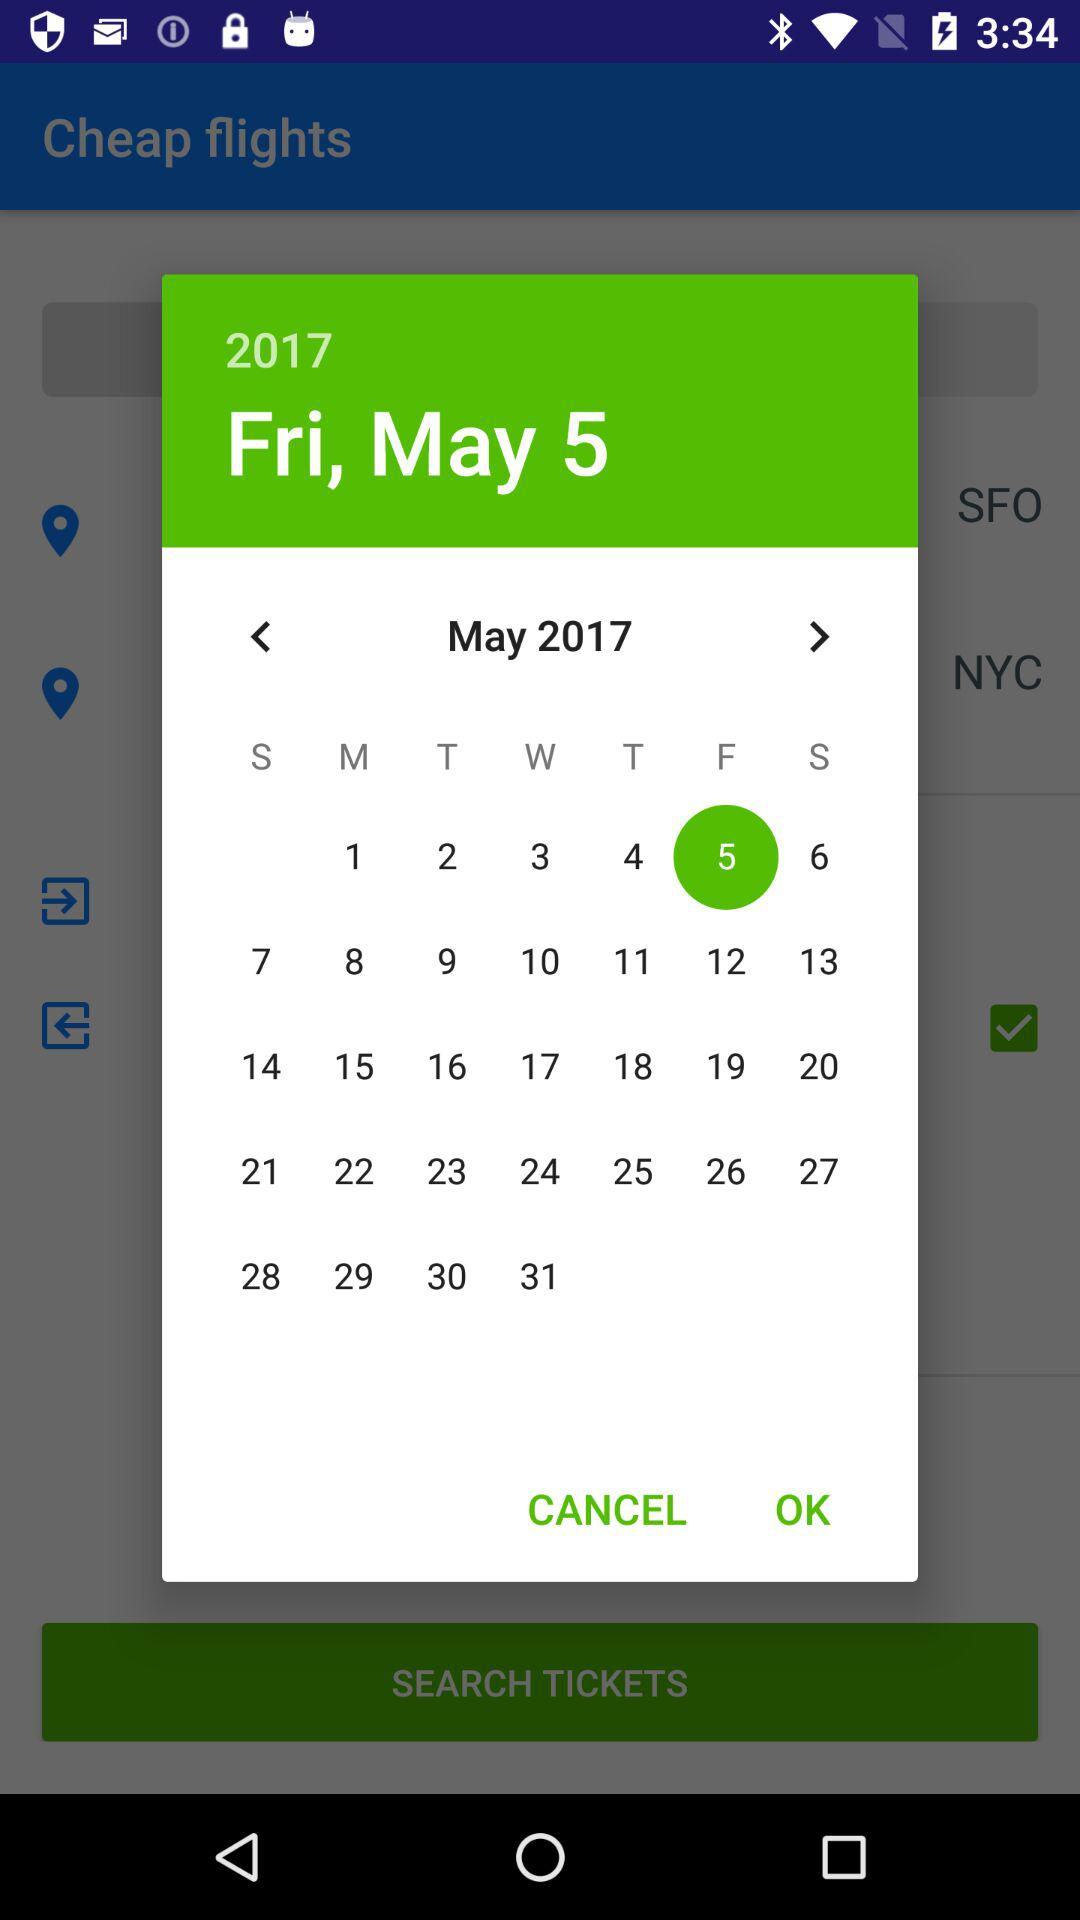What day is May 5? The day is Friday. 